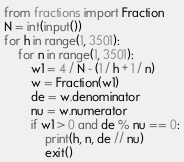<code> <loc_0><loc_0><loc_500><loc_500><_Python_>from fractions import Fraction
N = int(input())
for h in range(1, 3501):
    for n in range(1, 3501):
        w1 = 4 / N - (1 / h + 1 / n)
        w = Fraction(w1)
        de = w.denominator
        nu = w.numerator
        if w1 > 0 and de % nu == 0:
            print(h, n, de // nu)
            exit()</code> 